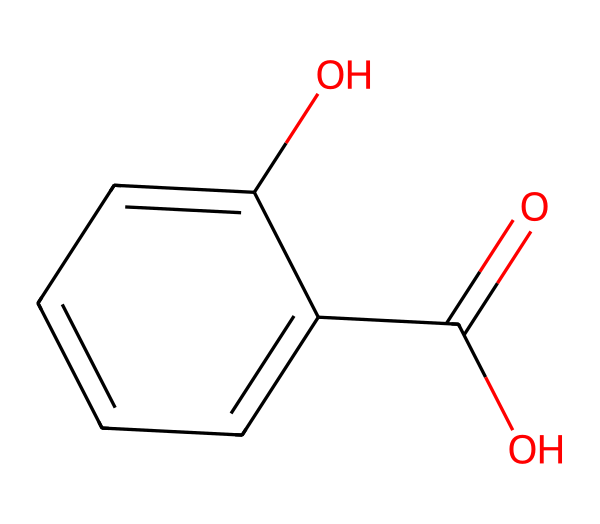What is the molecular formula of salicylic acid? The molecular formula is derived from the number of each type of atom in the structure. Counting the carbon (C), hydrogen (H), and oxygen (O) atoms gives C7H6O3.
Answer: C7H6O3 How many hydroxyl (–OH) groups are present in this molecule? The hydroxyl (–OH) groups can be identified in the structure. There is one –OH group attached to the benzene ring and one –OH part of the carboxylic acid functional group. Therefore, there are two –OH groups.
Answer: 2 What type of functional groups are present in this chemical? The functional groups can be identified by their common structures: the molecule has a carboxylic acid group (–COOH) and a hydroxyl group (–OH). Since both are present, they are the functional groups in salicylic acid.
Answer: carboxylic acid and hydroxyl How many carbon atoms are in the benzene ring? The benzene ring is part of the larger structure. From the SMILES representation, we can identify that there are six carbon atoms forming the hexagonal ring of benzene.
Answer: 6 Which functional group gives salicylic acid its acidic properties? The acidic properties stem from the presence of the carboxylic acid group (–COOH). This group can donate a proton (H+) in aqueous solutions, hence providing acidity.
Answer: carboxylic acid What type of chemical is salicylic acid classified as? Salicylic acid is classified as a phenolic compound due to the presence of the aromatic benzene ring combined with the hydroxyl group (–OH). This classification is typical for chemicals that contain a hydroxyl group directly bonded to an aromatic hydrocarbon.
Answer: phenolic compound 